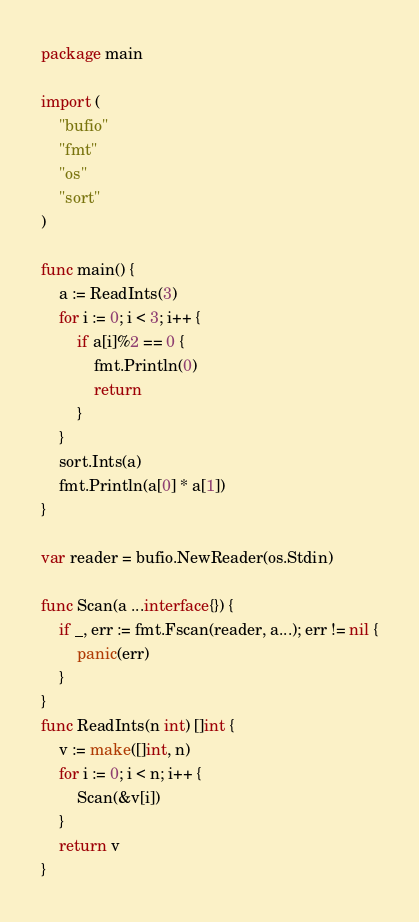Convert code to text. <code><loc_0><loc_0><loc_500><loc_500><_Go_>package main

import (
	"bufio"
	"fmt"
	"os"
	"sort"
)

func main() {
	a := ReadInts(3)
	for i := 0; i < 3; i++ {
		if a[i]%2 == 0 {
			fmt.Println(0)
			return
		}
	}
	sort.Ints(a)
	fmt.Println(a[0] * a[1])
}

var reader = bufio.NewReader(os.Stdin)

func Scan(a ...interface{}) {
	if _, err := fmt.Fscan(reader, a...); err != nil {
		panic(err)
	}
}
func ReadInts(n int) []int {
	v := make([]int, n)
	for i := 0; i < n; i++ {
		Scan(&v[i])
	}
	return v
}
</code> 